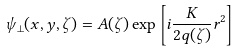<formula> <loc_0><loc_0><loc_500><loc_500>\psi _ { \perp } ( x , y , \zeta ) = A ( \zeta ) \exp \left [ i \frac { K } { 2 q ( \zeta ) } r ^ { 2 } \right ]</formula> 